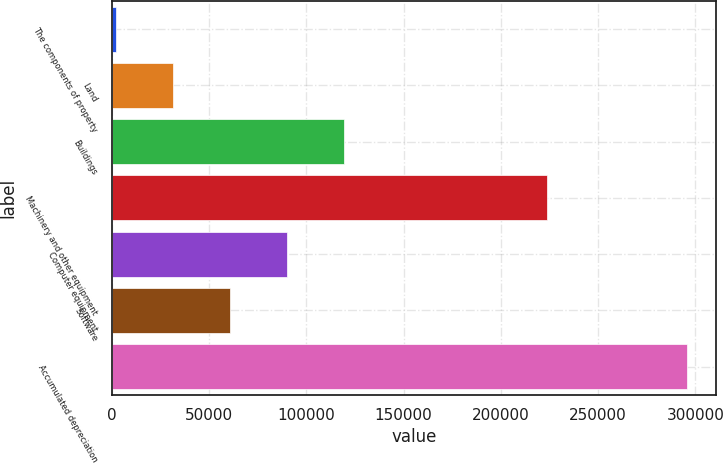<chart> <loc_0><loc_0><loc_500><loc_500><bar_chart><fcel>The components of property<fcel>Land<fcel>Buildings<fcel>Machinery and other equipment<fcel>Computer equipment<fcel>Software<fcel>Accumulated depreciation<nl><fcel>2015<fcel>31371.1<fcel>119439<fcel>223561<fcel>90083.3<fcel>60727.2<fcel>295576<nl></chart> 